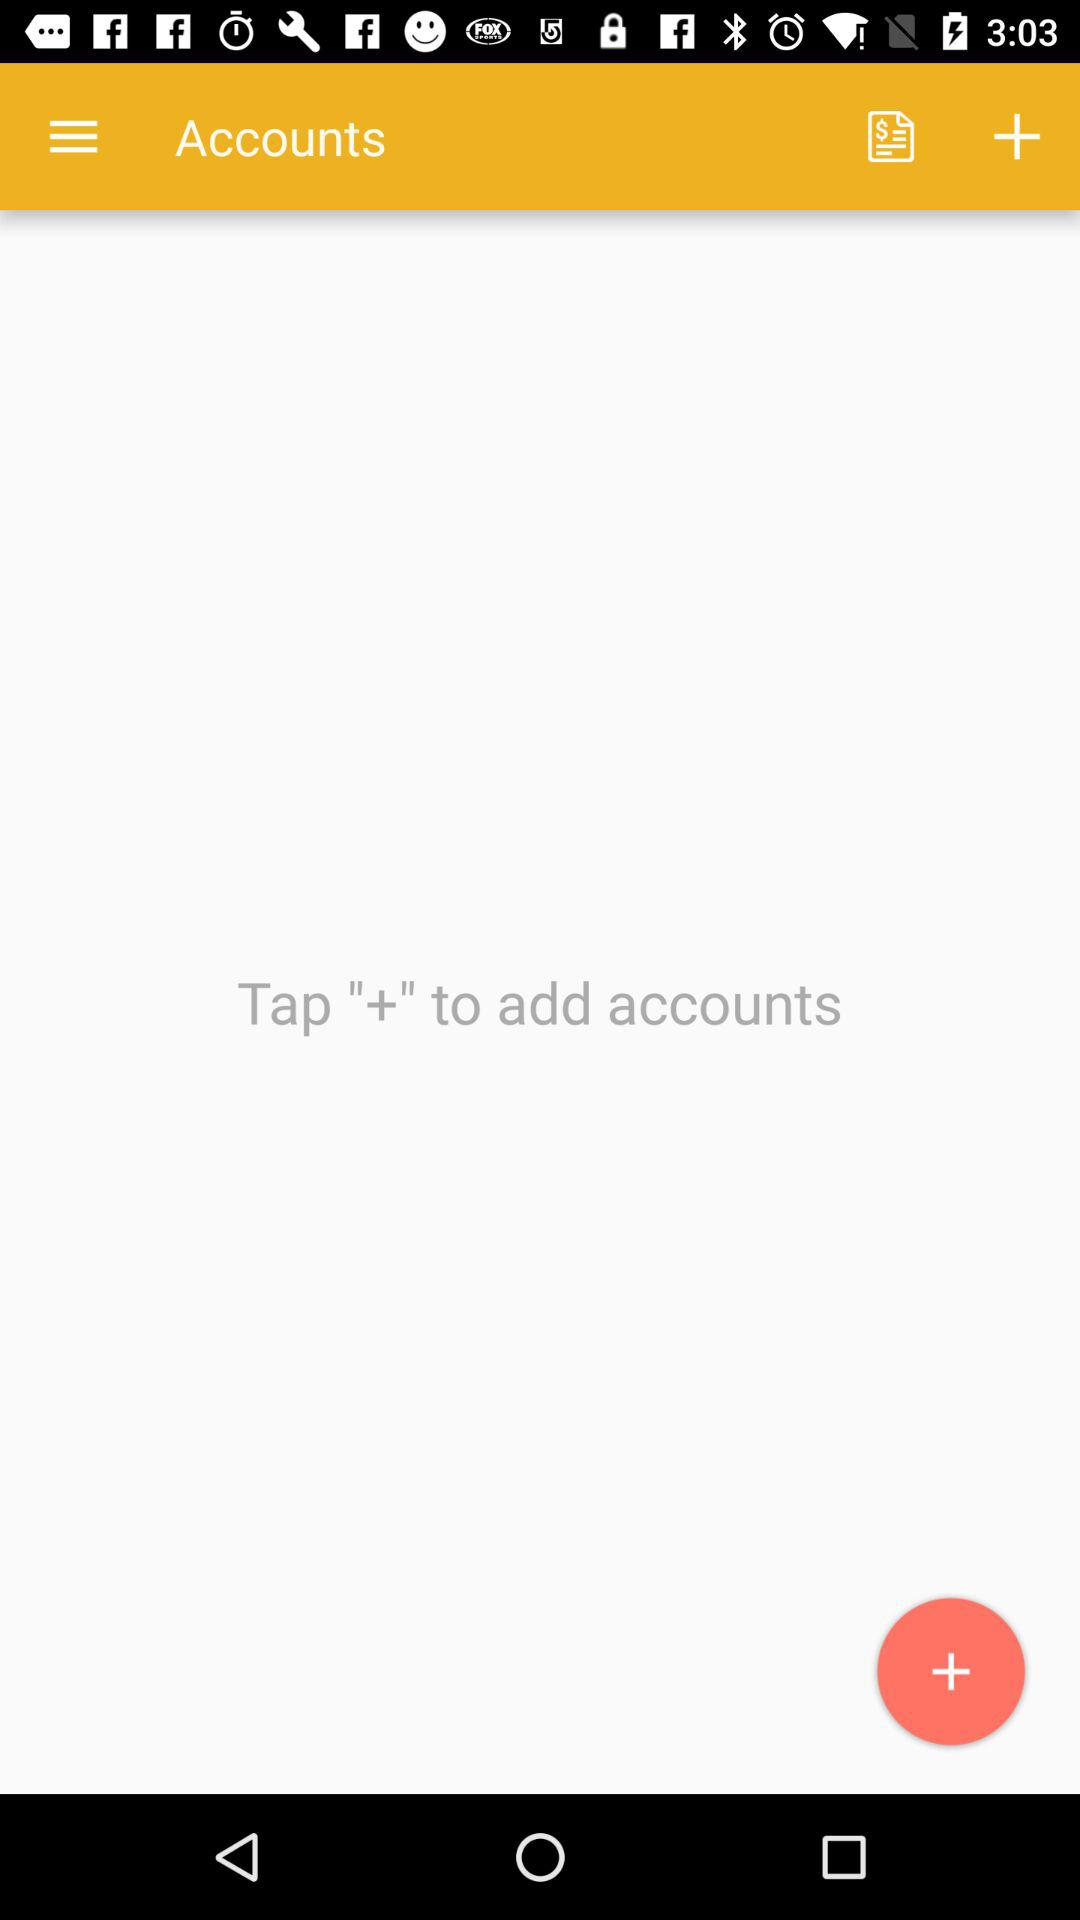What do I do to add the accounts? To add accounts, tap "+". 